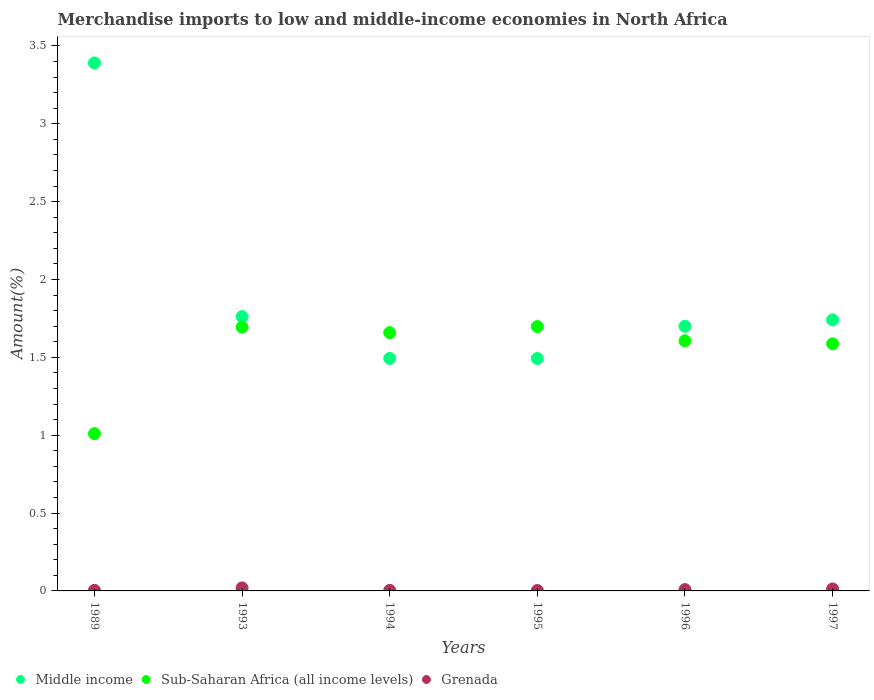Is the number of dotlines equal to the number of legend labels?
Keep it short and to the point. Yes. What is the percentage of amount earned from merchandise imports in Sub-Saharan Africa (all income levels) in 1997?
Your answer should be very brief. 1.59. Across all years, what is the maximum percentage of amount earned from merchandise imports in Grenada?
Ensure brevity in your answer.  0.02. Across all years, what is the minimum percentage of amount earned from merchandise imports in Sub-Saharan Africa (all income levels)?
Give a very brief answer. 1.01. What is the total percentage of amount earned from merchandise imports in Grenada in the graph?
Your answer should be very brief. 0.05. What is the difference between the percentage of amount earned from merchandise imports in Sub-Saharan Africa (all income levels) in 1989 and that in 1993?
Offer a very short reply. -0.68. What is the difference between the percentage of amount earned from merchandise imports in Middle income in 1993 and the percentage of amount earned from merchandise imports in Sub-Saharan Africa (all income levels) in 1994?
Offer a very short reply. 0.1. What is the average percentage of amount earned from merchandise imports in Sub-Saharan Africa (all income levels) per year?
Offer a terse response. 1.54. In the year 1993, what is the difference between the percentage of amount earned from merchandise imports in Sub-Saharan Africa (all income levels) and percentage of amount earned from merchandise imports in Grenada?
Make the answer very short. 1.67. In how many years, is the percentage of amount earned from merchandise imports in Sub-Saharan Africa (all income levels) greater than 1 %?
Make the answer very short. 6. What is the ratio of the percentage of amount earned from merchandise imports in Grenada in 1989 to that in 1996?
Your response must be concise. 0.45. Is the percentage of amount earned from merchandise imports in Sub-Saharan Africa (all income levels) in 1994 less than that in 1996?
Your answer should be very brief. No. Is the difference between the percentage of amount earned from merchandise imports in Sub-Saharan Africa (all income levels) in 1994 and 1996 greater than the difference between the percentage of amount earned from merchandise imports in Grenada in 1994 and 1996?
Offer a terse response. Yes. What is the difference between the highest and the second highest percentage of amount earned from merchandise imports in Grenada?
Your response must be concise. 0.01. What is the difference between the highest and the lowest percentage of amount earned from merchandise imports in Grenada?
Give a very brief answer. 0.02. Is it the case that in every year, the sum of the percentage of amount earned from merchandise imports in Grenada and percentage of amount earned from merchandise imports in Sub-Saharan Africa (all income levels)  is greater than the percentage of amount earned from merchandise imports in Middle income?
Offer a very short reply. No. How many years are there in the graph?
Provide a short and direct response. 6. Are the values on the major ticks of Y-axis written in scientific E-notation?
Your answer should be compact. No. Does the graph contain any zero values?
Offer a very short reply. No. Does the graph contain grids?
Keep it short and to the point. No. Where does the legend appear in the graph?
Make the answer very short. Bottom left. How are the legend labels stacked?
Offer a very short reply. Horizontal. What is the title of the graph?
Your answer should be very brief. Merchandise imports to low and middle-income economies in North Africa. What is the label or title of the X-axis?
Offer a very short reply. Years. What is the label or title of the Y-axis?
Keep it short and to the point. Amount(%). What is the Amount(%) in Middle income in 1989?
Make the answer very short. 3.39. What is the Amount(%) of Sub-Saharan Africa (all income levels) in 1989?
Offer a very short reply. 1.01. What is the Amount(%) in Grenada in 1989?
Provide a short and direct response. 0. What is the Amount(%) in Middle income in 1993?
Offer a very short reply. 1.76. What is the Amount(%) of Sub-Saharan Africa (all income levels) in 1993?
Give a very brief answer. 1.69. What is the Amount(%) of Grenada in 1993?
Ensure brevity in your answer.  0.02. What is the Amount(%) of Middle income in 1994?
Give a very brief answer. 1.49. What is the Amount(%) of Sub-Saharan Africa (all income levels) in 1994?
Your answer should be compact. 1.66. What is the Amount(%) of Grenada in 1994?
Ensure brevity in your answer.  0. What is the Amount(%) in Middle income in 1995?
Provide a succinct answer. 1.49. What is the Amount(%) of Sub-Saharan Africa (all income levels) in 1995?
Provide a short and direct response. 1.7. What is the Amount(%) of Grenada in 1995?
Keep it short and to the point. 0. What is the Amount(%) in Middle income in 1996?
Provide a short and direct response. 1.7. What is the Amount(%) of Sub-Saharan Africa (all income levels) in 1996?
Your answer should be compact. 1.61. What is the Amount(%) in Grenada in 1996?
Offer a very short reply. 0.01. What is the Amount(%) in Middle income in 1997?
Provide a succinct answer. 1.74. What is the Amount(%) of Sub-Saharan Africa (all income levels) in 1997?
Your response must be concise. 1.59. What is the Amount(%) in Grenada in 1997?
Ensure brevity in your answer.  0.01. Across all years, what is the maximum Amount(%) of Middle income?
Your response must be concise. 3.39. Across all years, what is the maximum Amount(%) of Sub-Saharan Africa (all income levels)?
Give a very brief answer. 1.7. Across all years, what is the maximum Amount(%) in Grenada?
Make the answer very short. 0.02. Across all years, what is the minimum Amount(%) in Middle income?
Provide a succinct answer. 1.49. Across all years, what is the minimum Amount(%) in Sub-Saharan Africa (all income levels)?
Your response must be concise. 1.01. Across all years, what is the minimum Amount(%) of Grenada?
Your answer should be very brief. 0. What is the total Amount(%) in Middle income in the graph?
Your answer should be compact. 11.58. What is the total Amount(%) in Sub-Saharan Africa (all income levels) in the graph?
Your answer should be compact. 9.25. What is the total Amount(%) in Grenada in the graph?
Provide a succinct answer. 0.05. What is the difference between the Amount(%) in Middle income in 1989 and that in 1993?
Your answer should be compact. 1.63. What is the difference between the Amount(%) of Sub-Saharan Africa (all income levels) in 1989 and that in 1993?
Ensure brevity in your answer.  -0.68. What is the difference between the Amount(%) of Grenada in 1989 and that in 1993?
Your answer should be compact. -0.02. What is the difference between the Amount(%) in Middle income in 1989 and that in 1994?
Keep it short and to the point. 1.9. What is the difference between the Amount(%) of Sub-Saharan Africa (all income levels) in 1989 and that in 1994?
Give a very brief answer. -0.65. What is the difference between the Amount(%) in Middle income in 1989 and that in 1995?
Offer a terse response. 1.9. What is the difference between the Amount(%) of Sub-Saharan Africa (all income levels) in 1989 and that in 1995?
Your answer should be very brief. -0.69. What is the difference between the Amount(%) of Grenada in 1989 and that in 1995?
Your answer should be compact. 0. What is the difference between the Amount(%) of Middle income in 1989 and that in 1996?
Your answer should be very brief. 1.69. What is the difference between the Amount(%) in Sub-Saharan Africa (all income levels) in 1989 and that in 1996?
Offer a very short reply. -0.6. What is the difference between the Amount(%) in Grenada in 1989 and that in 1996?
Provide a succinct answer. -0. What is the difference between the Amount(%) in Middle income in 1989 and that in 1997?
Ensure brevity in your answer.  1.65. What is the difference between the Amount(%) of Sub-Saharan Africa (all income levels) in 1989 and that in 1997?
Provide a short and direct response. -0.58. What is the difference between the Amount(%) of Grenada in 1989 and that in 1997?
Your response must be concise. -0.01. What is the difference between the Amount(%) in Middle income in 1993 and that in 1994?
Give a very brief answer. 0.27. What is the difference between the Amount(%) of Sub-Saharan Africa (all income levels) in 1993 and that in 1994?
Provide a succinct answer. 0.04. What is the difference between the Amount(%) in Grenada in 1993 and that in 1994?
Your response must be concise. 0.02. What is the difference between the Amount(%) of Middle income in 1993 and that in 1995?
Give a very brief answer. 0.27. What is the difference between the Amount(%) of Sub-Saharan Africa (all income levels) in 1993 and that in 1995?
Ensure brevity in your answer.  -0. What is the difference between the Amount(%) of Grenada in 1993 and that in 1995?
Keep it short and to the point. 0.02. What is the difference between the Amount(%) of Middle income in 1993 and that in 1996?
Your answer should be very brief. 0.06. What is the difference between the Amount(%) of Sub-Saharan Africa (all income levels) in 1993 and that in 1996?
Keep it short and to the point. 0.09. What is the difference between the Amount(%) in Grenada in 1993 and that in 1996?
Your answer should be very brief. 0.01. What is the difference between the Amount(%) in Middle income in 1993 and that in 1997?
Your answer should be very brief. 0.02. What is the difference between the Amount(%) of Sub-Saharan Africa (all income levels) in 1993 and that in 1997?
Offer a very short reply. 0.11. What is the difference between the Amount(%) of Grenada in 1993 and that in 1997?
Your answer should be compact. 0.01. What is the difference between the Amount(%) of Middle income in 1994 and that in 1995?
Your answer should be very brief. 0. What is the difference between the Amount(%) of Sub-Saharan Africa (all income levels) in 1994 and that in 1995?
Your answer should be very brief. -0.04. What is the difference between the Amount(%) of Grenada in 1994 and that in 1995?
Offer a very short reply. 0. What is the difference between the Amount(%) in Middle income in 1994 and that in 1996?
Your answer should be compact. -0.21. What is the difference between the Amount(%) in Sub-Saharan Africa (all income levels) in 1994 and that in 1996?
Your answer should be very brief. 0.05. What is the difference between the Amount(%) of Grenada in 1994 and that in 1996?
Your response must be concise. -0. What is the difference between the Amount(%) in Middle income in 1994 and that in 1997?
Make the answer very short. -0.25. What is the difference between the Amount(%) of Sub-Saharan Africa (all income levels) in 1994 and that in 1997?
Your answer should be very brief. 0.07. What is the difference between the Amount(%) of Grenada in 1994 and that in 1997?
Your answer should be very brief. -0.01. What is the difference between the Amount(%) in Middle income in 1995 and that in 1996?
Provide a succinct answer. -0.21. What is the difference between the Amount(%) of Sub-Saharan Africa (all income levels) in 1995 and that in 1996?
Offer a terse response. 0.09. What is the difference between the Amount(%) of Grenada in 1995 and that in 1996?
Make the answer very short. -0.01. What is the difference between the Amount(%) in Middle income in 1995 and that in 1997?
Give a very brief answer. -0.25. What is the difference between the Amount(%) of Sub-Saharan Africa (all income levels) in 1995 and that in 1997?
Provide a short and direct response. 0.11. What is the difference between the Amount(%) in Grenada in 1995 and that in 1997?
Make the answer very short. -0.01. What is the difference between the Amount(%) of Middle income in 1996 and that in 1997?
Provide a short and direct response. -0.04. What is the difference between the Amount(%) in Sub-Saharan Africa (all income levels) in 1996 and that in 1997?
Your response must be concise. 0.02. What is the difference between the Amount(%) of Grenada in 1996 and that in 1997?
Ensure brevity in your answer.  -0. What is the difference between the Amount(%) of Middle income in 1989 and the Amount(%) of Sub-Saharan Africa (all income levels) in 1993?
Offer a terse response. 1.7. What is the difference between the Amount(%) in Middle income in 1989 and the Amount(%) in Grenada in 1993?
Your answer should be very brief. 3.37. What is the difference between the Amount(%) of Sub-Saharan Africa (all income levels) in 1989 and the Amount(%) of Grenada in 1993?
Your answer should be compact. 0.99. What is the difference between the Amount(%) of Middle income in 1989 and the Amount(%) of Sub-Saharan Africa (all income levels) in 1994?
Offer a very short reply. 1.73. What is the difference between the Amount(%) of Middle income in 1989 and the Amount(%) of Grenada in 1994?
Your response must be concise. 3.39. What is the difference between the Amount(%) of Sub-Saharan Africa (all income levels) in 1989 and the Amount(%) of Grenada in 1994?
Provide a succinct answer. 1.01. What is the difference between the Amount(%) in Middle income in 1989 and the Amount(%) in Sub-Saharan Africa (all income levels) in 1995?
Provide a succinct answer. 1.69. What is the difference between the Amount(%) of Middle income in 1989 and the Amount(%) of Grenada in 1995?
Ensure brevity in your answer.  3.39. What is the difference between the Amount(%) in Sub-Saharan Africa (all income levels) in 1989 and the Amount(%) in Grenada in 1995?
Offer a very short reply. 1.01. What is the difference between the Amount(%) of Middle income in 1989 and the Amount(%) of Sub-Saharan Africa (all income levels) in 1996?
Your answer should be compact. 1.78. What is the difference between the Amount(%) of Middle income in 1989 and the Amount(%) of Grenada in 1996?
Provide a short and direct response. 3.38. What is the difference between the Amount(%) in Middle income in 1989 and the Amount(%) in Sub-Saharan Africa (all income levels) in 1997?
Make the answer very short. 1.8. What is the difference between the Amount(%) in Middle income in 1989 and the Amount(%) in Grenada in 1997?
Your response must be concise. 3.38. What is the difference between the Amount(%) in Middle income in 1993 and the Amount(%) in Sub-Saharan Africa (all income levels) in 1994?
Provide a short and direct response. 0.1. What is the difference between the Amount(%) in Middle income in 1993 and the Amount(%) in Grenada in 1994?
Offer a very short reply. 1.76. What is the difference between the Amount(%) in Sub-Saharan Africa (all income levels) in 1993 and the Amount(%) in Grenada in 1994?
Your answer should be very brief. 1.69. What is the difference between the Amount(%) of Middle income in 1993 and the Amount(%) of Sub-Saharan Africa (all income levels) in 1995?
Your response must be concise. 0.06. What is the difference between the Amount(%) of Middle income in 1993 and the Amount(%) of Grenada in 1995?
Your answer should be compact. 1.76. What is the difference between the Amount(%) in Sub-Saharan Africa (all income levels) in 1993 and the Amount(%) in Grenada in 1995?
Provide a succinct answer. 1.69. What is the difference between the Amount(%) in Middle income in 1993 and the Amount(%) in Sub-Saharan Africa (all income levels) in 1996?
Offer a very short reply. 0.16. What is the difference between the Amount(%) in Middle income in 1993 and the Amount(%) in Grenada in 1996?
Offer a very short reply. 1.75. What is the difference between the Amount(%) in Sub-Saharan Africa (all income levels) in 1993 and the Amount(%) in Grenada in 1996?
Provide a succinct answer. 1.69. What is the difference between the Amount(%) in Middle income in 1993 and the Amount(%) in Sub-Saharan Africa (all income levels) in 1997?
Provide a short and direct response. 0.17. What is the difference between the Amount(%) in Middle income in 1993 and the Amount(%) in Grenada in 1997?
Make the answer very short. 1.75. What is the difference between the Amount(%) of Sub-Saharan Africa (all income levels) in 1993 and the Amount(%) of Grenada in 1997?
Your answer should be compact. 1.68. What is the difference between the Amount(%) of Middle income in 1994 and the Amount(%) of Sub-Saharan Africa (all income levels) in 1995?
Make the answer very short. -0.2. What is the difference between the Amount(%) of Middle income in 1994 and the Amount(%) of Grenada in 1995?
Your answer should be very brief. 1.49. What is the difference between the Amount(%) of Sub-Saharan Africa (all income levels) in 1994 and the Amount(%) of Grenada in 1995?
Your answer should be very brief. 1.66. What is the difference between the Amount(%) of Middle income in 1994 and the Amount(%) of Sub-Saharan Africa (all income levels) in 1996?
Your answer should be very brief. -0.11. What is the difference between the Amount(%) in Middle income in 1994 and the Amount(%) in Grenada in 1996?
Give a very brief answer. 1.49. What is the difference between the Amount(%) of Sub-Saharan Africa (all income levels) in 1994 and the Amount(%) of Grenada in 1996?
Give a very brief answer. 1.65. What is the difference between the Amount(%) of Middle income in 1994 and the Amount(%) of Sub-Saharan Africa (all income levels) in 1997?
Provide a short and direct response. -0.09. What is the difference between the Amount(%) in Middle income in 1994 and the Amount(%) in Grenada in 1997?
Your answer should be very brief. 1.48. What is the difference between the Amount(%) in Sub-Saharan Africa (all income levels) in 1994 and the Amount(%) in Grenada in 1997?
Provide a succinct answer. 1.65. What is the difference between the Amount(%) in Middle income in 1995 and the Amount(%) in Sub-Saharan Africa (all income levels) in 1996?
Give a very brief answer. -0.11. What is the difference between the Amount(%) in Middle income in 1995 and the Amount(%) in Grenada in 1996?
Provide a succinct answer. 1.48. What is the difference between the Amount(%) of Sub-Saharan Africa (all income levels) in 1995 and the Amount(%) of Grenada in 1996?
Keep it short and to the point. 1.69. What is the difference between the Amount(%) of Middle income in 1995 and the Amount(%) of Sub-Saharan Africa (all income levels) in 1997?
Offer a very short reply. -0.09. What is the difference between the Amount(%) of Middle income in 1995 and the Amount(%) of Grenada in 1997?
Your answer should be very brief. 1.48. What is the difference between the Amount(%) in Sub-Saharan Africa (all income levels) in 1995 and the Amount(%) in Grenada in 1997?
Ensure brevity in your answer.  1.68. What is the difference between the Amount(%) of Middle income in 1996 and the Amount(%) of Sub-Saharan Africa (all income levels) in 1997?
Your answer should be very brief. 0.11. What is the difference between the Amount(%) in Middle income in 1996 and the Amount(%) in Grenada in 1997?
Ensure brevity in your answer.  1.69. What is the difference between the Amount(%) of Sub-Saharan Africa (all income levels) in 1996 and the Amount(%) of Grenada in 1997?
Your answer should be very brief. 1.59. What is the average Amount(%) of Middle income per year?
Give a very brief answer. 1.93. What is the average Amount(%) of Sub-Saharan Africa (all income levels) per year?
Your answer should be compact. 1.54. What is the average Amount(%) in Grenada per year?
Your response must be concise. 0.01. In the year 1989, what is the difference between the Amount(%) in Middle income and Amount(%) in Sub-Saharan Africa (all income levels)?
Offer a terse response. 2.38. In the year 1989, what is the difference between the Amount(%) in Middle income and Amount(%) in Grenada?
Ensure brevity in your answer.  3.39. In the year 1989, what is the difference between the Amount(%) in Sub-Saharan Africa (all income levels) and Amount(%) in Grenada?
Offer a terse response. 1.01. In the year 1993, what is the difference between the Amount(%) of Middle income and Amount(%) of Sub-Saharan Africa (all income levels)?
Give a very brief answer. 0.07. In the year 1993, what is the difference between the Amount(%) in Middle income and Amount(%) in Grenada?
Your answer should be very brief. 1.74. In the year 1993, what is the difference between the Amount(%) in Sub-Saharan Africa (all income levels) and Amount(%) in Grenada?
Ensure brevity in your answer.  1.68. In the year 1994, what is the difference between the Amount(%) in Middle income and Amount(%) in Sub-Saharan Africa (all income levels)?
Provide a short and direct response. -0.17. In the year 1994, what is the difference between the Amount(%) of Middle income and Amount(%) of Grenada?
Make the answer very short. 1.49. In the year 1994, what is the difference between the Amount(%) of Sub-Saharan Africa (all income levels) and Amount(%) of Grenada?
Offer a very short reply. 1.65. In the year 1995, what is the difference between the Amount(%) of Middle income and Amount(%) of Sub-Saharan Africa (all income levels)?
Keep it short and to the point. -0.2. In the year 1995, what is the difference between the Amount(%) of Middle income and Amount(%) of Grenada?
Provide a succinct answer. 1.49. In the year 1995, what is the difference between the Amount(%) of Sub-Saharan Africa (all income levels) and Amount(%) of Grenada?
Make the answer very short. 1.69. In the year 1996, what is the difference between the Amount(%) in Middle income and Amount(%) in Sub-Saharan Africa (all income levels)?
Keep it short and to the point. 0.09. In the year 1996, what is the difference between the Amount(%) in Middle income and Amount(%) in Grenada?
Keep it short and to the point. 1.69. In the year 1996, what is the difference between the Amount(%) of Sub-Saharan Africa (all income levels) and Amount(%) of Grenada?
Your response must be concise. 1.6. In the year 1997, what is the difference between the Amount(%) of Middle income and Amount(%) of Sub-Saharan Africa (all income levels)?
Your answer should be compact. 0.15. In the year 1997, what is the difference between the Amount(%) of Middle income and Amount(%) of Grenada?
Provide a succinct answer. 1.73. In the year 1997, what is the difference between the Amount(%) of Sub-Saharan Africa (all income levels) and Amount(%) of Grenada?
Ensure brevity in your answer.  1.57. What is the ratio of the Amount(%) in Middle income in 1989 to that in 1993?
Your response must be concise. 1.92. What is the ratio of the Amount(%) of Sub-Saharan Africa (all income levels) in 1989 to that in 1993?
Your response must be concise. 0.6. What is the ratio of the Amount(%) of Grenada in 1989 to that in 1993?
Offer a very short reply. 0.19. What is the ratio of the Amount(%) in Middle income in 1989 to that in 1994?
Make the answer very short. 2.27. What is the ratio of the Amount(%) of Sub-Saharan Africa (all income levels) in 1989 to that in 1994?
Give a very brief answer. 0.61. What is the ratio of the Amount(%) in Grenada in 1989 to that in 1994?
Your response must be concise. 1.04. What is the ratio of the Amount(%) of Middle income in 1989 to that in 1995?
Provide a short and direct response. 2.27. What is the ratio of the Amount(%) of Sub-Saharan Africa (all income levels) in 1989 to that in 1995?
Keep it short and to the point. 0.59. What is the ratio of the Amount(%) of Grenada in 1989 to that in 1995?
Give a very brief answer. 1.36. What is the ratio of the Amount(%) in Middle income in 1989 to that in 1996?
Offer a very short reply. 1.99. What is the ratio of the Amount(%) in Sub-Saharan Africa (all income levels) in 1989 to that in 1996?
Make the answer very short. 0.63. What is the ratio of the Amount(%) in Grenada in 1989 to that in 1996?
Make the answer very short. 0.45. What is the ratio of the Amount(%) in Middle income in 1989 to that in 1997?
Make the answer very short. 1.95. What is the ratio of the Amount(%) in Sub-Saharan Africa (all income levels) in 1989 to that in 1997?
Your answer should be very brief. 0.64. What is the ratio of the Amount(%) of Grenada in 1989 to that in 1997?
Provide a succinct answer. 0.29. What is the ratio of the Amount(%) in Middle income in 1993 to that in 1994?
Offer a terse response. 1.18. What is the ratio of the Amount(%) in Sub-Saharan Africa (all income levels) in 1993 to that in 1994?
Your response must be concise. 1.02. What is the ratio of the Amount(%) in Grenada in 1993 to that in 1994?
Make the answer very short. 5.34. What is the ratio of the Amount(%) in Middle income in 1993 to that in 1995?
Make the answer very short. 1.18. What is the ratio of the Amount(%) in Grenada in 1993 to that in 1995?
Your answer should be very brief. 6.98. What is the ratio of the Amount(%) of Middle income in 1993 to that in 1996?
Make the answer very short. 1.04. What is the ratio of the Amount(%) of Sub-Saharan Africa (all income levels) in 1993 to that in 1996?
Make the answer very short. 1.05. What is the ratio of the Amount(%) of Grenada in 1993 to that in 1996?
Offer a terse response. 2.3. What is the ratio of the Amount(%) of Middle income in 1993 to that in 1997?
Provide a short and direct response. 1.01. What is the ratio of the Amount(%) in Sub-Saharan Africa (all income levels) in 1993 to that in 1997?
Keep it short and to the point. 1.07. What is the ratio of the Amount(%) in Grenada in 1993 to that in 1997?
Provide a short and direct response. 1.52. What is the ratio of the Amount(%) of Grenada in 1994 to that in 1995?
Your answer should be compact. 1.31. What is the ratio of the Amount(%) of Middle income in 1994 to that in 1996?
Your response must be concise. 0.88. What is the ratio of the Amount(%) in Sub-Saharan Africa (all income levels) in 1994 to that in 1996?
Make the answer very short. 1.03. What is the ratio of the Amount(%) in Grenada in 1994 to that in 1996?
Provide a succinct answer. 0.43. What is the ratio of the Amount(%) of Middle income in 1994 to that in 1997?
Your answer should be very brief. 0.86. What is the ratio of the Amount(%) of Sub-Saharan Africa (all income levels) in 1994 to that in 1997?
Offer a very short reply. 1.05. What is the ratio of the Amount(%) in Grenada in 1994 to that in 1997?
Offer a very short reply. 0.28. What is the ratio of the Amount(%) of Middle income in 1995 to that in 1996?
Keep it short and to the point. 0.88. What is the ratio of the Amount(%) in Sub-Saharan Africa (all income levels) in 1995 to that in 1996?
Provide a short and direct response. 1.06. What is the ratio of the Amount(%) of Grenada in 1995 to that in 1996?
Offer a very short reply. 0.33. What is the ratio of the Amount(%) of Middle income in 1995 to that in 1997?
Make the answer very short. 0.86. What is the ratio of the Amount(%) in Sub-Saharan Africa (all income levels) in 1995 to that in 1997?
Provide a short and direct response. 1.07. What is the ratio of the Amount(%) of Grenada in 1995 to that in 1997?
Keep it short and to the point. 0.22. What is the ratio of the Amount(%) of Middle income in 1996 to that in 1997?
Keep it short and to the point. 0.98. What is the ratio of the Amount(%) in Sub-Saharan Africa (all income levels) in 1996 to that in 1997?
Give a very brief answer. 1.01. What is the ratio of the Amount(%) in Grenada in 1996 to that in 1997?
Provide a short and direct response. 0.66. What is the difference between the highest and the second highest Amount(%) of Middle income?
Ensure brevity in your answer.  1.63. What is the difference between the highest and the second highest Amount(%) in Sub-Saharan Africa (all income levels)?
Offer a terse response. 0. What is the difference between the highest and the second highest Amount(%) in Grenada?
Offer a terse response. 0.01. What is the difference between the highest and the lowest Amount(%) in Middle income?
Provide a succinct answer. 1.9. What is the difference between the highest and the lowest Amount(%) of Sub-Saharan Africa (all income levels)?
Give a very brief answer. 0.69. What is the difference between the highest and the lowest Amount(%) in Grenada?
Provide a short and direct response. 0.02. 